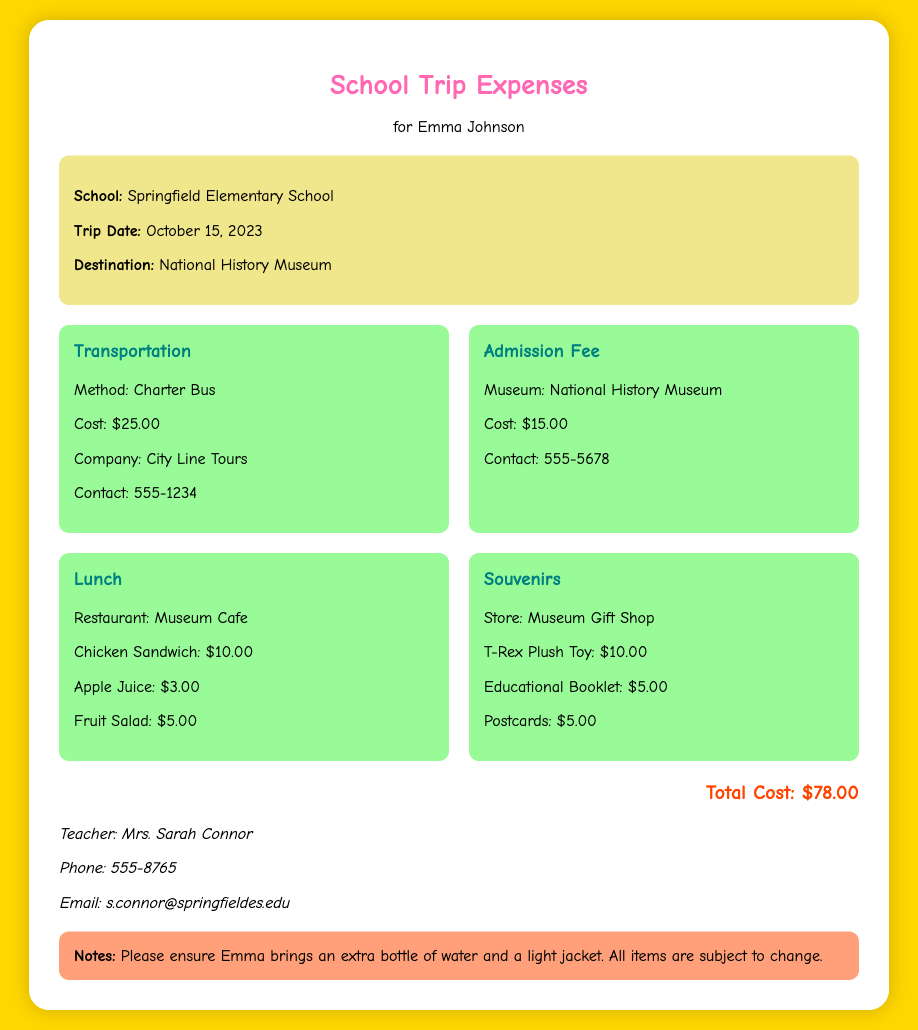what is the name of the student? The document specifies the name of the student for whom the expenses are outlined, which is Emma Johnson.
Answer: Emma Johnson what is the total cost of the trip? The total cost is clearly mentioned at the bottom of the document, which is the sum of all expenses listed.
Answer: $78.00 who is the teacher accompanying the trip? The document provides the name of the teacher responsible for the trip, which is mentioned in the contact section.
Answer: Mrs. Sarah Connor what type of transportation was used? The document states the method of transportation used for the school trip, found in the expenses section.
Answer: Charter Bus what is the admission fee to the museum? The admission fee for the National History Museum is specified in the expenses section of the document.
Answer: $15.00 how much did the T-Rex plush toy cost? The document lists the cost of the T-Rex plush toy as part of the souvenirs in the expenses section.
Answer: $10.00 what date did the school trip take place? The date of the trip is provided in the information section at the start of the document.
Answer: October 15, 2023 who can be contacted for more information? The document includes contact information for the teacher, which indicates who to reach out to for more details.
Answer: Mrs. Sarah Connor what items did the lunch include? The document details the lunch items purchased, which are listed in the expenses section related to the lunch.
Answer: Chicken Sandwich, Apple Juice, Fruit Salad 